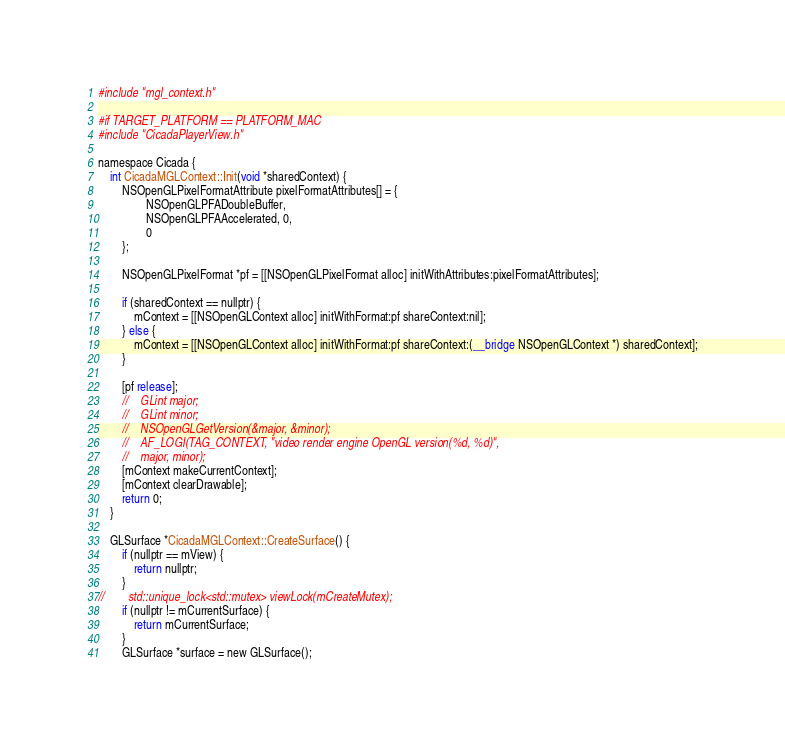<code> <loc_0><loc_0><loc_500><loc_500><_ObjectiveC_>#include "mgl_context.h"

#if TARGET_PLATFORM == PLATFORM_MAC
#include "CicadaPlayerView.h"

namespace Cicada {
    int CicadaMGLContext::Init(void *sharedContext) {
        NSOpenGLPixelFormatAttribute pixelFormatAttributes[] = {
                NSOpenGLPFADoubleBuffer,
                NSOpenGLPFAAccelerated, 0,
                0
        };

        NSOpenGLPixelFormat *pf = [[NSOpenGLPixelFormat alloc] initWithAttributes:pixelFormatAttributes];

        if (sharedContext == nullptr) {
            mContext = [[NSOpenGLContext alloc] initWithFormat:pf shareContext:nil];
        } else {
            mContext = [[NSOpenGLContext alloc] initWithFormat:pf shareContext:(__bridge NSOpenGLContext *) sharedContext];
        }

        [pf release];
        //    GLint major;
        //    GLint minor;
        //    NSOpenGLGetVersion(&major, &minor);
        //    AF_LOGI(TAG_CONTEXT, "video render engine OpenGL version(%d, %d)",
        //    major, minor);
        [mContext makeCurrentContext];
        [mContext clearDrawable];
        return 0;
    }

    GLSurface *CicadaMGLContext::CreateSurface() {
        if (nullptr == mView) {
            return nullptr;
        }
//        std::unique_lock<std::mutex> viewLock(mCreateMutex);
        if (nullptr != mCurrentSurface) {
            return mCurrentSurface;
        }
        GLSurface *surface = new GLSurface();</code> 